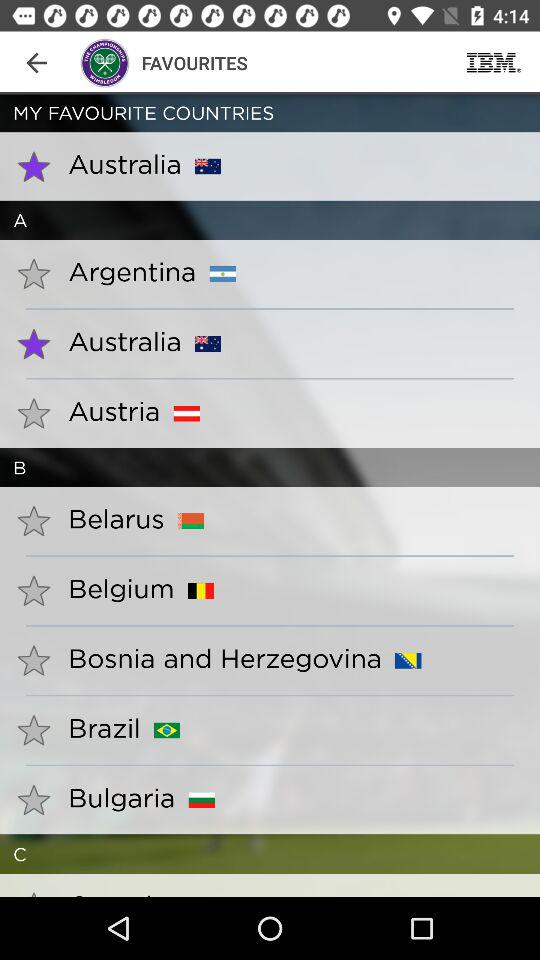Which country has been mentioned in "MY FAVOURITE COUNTRIES"? The mentioned country is Australia. 